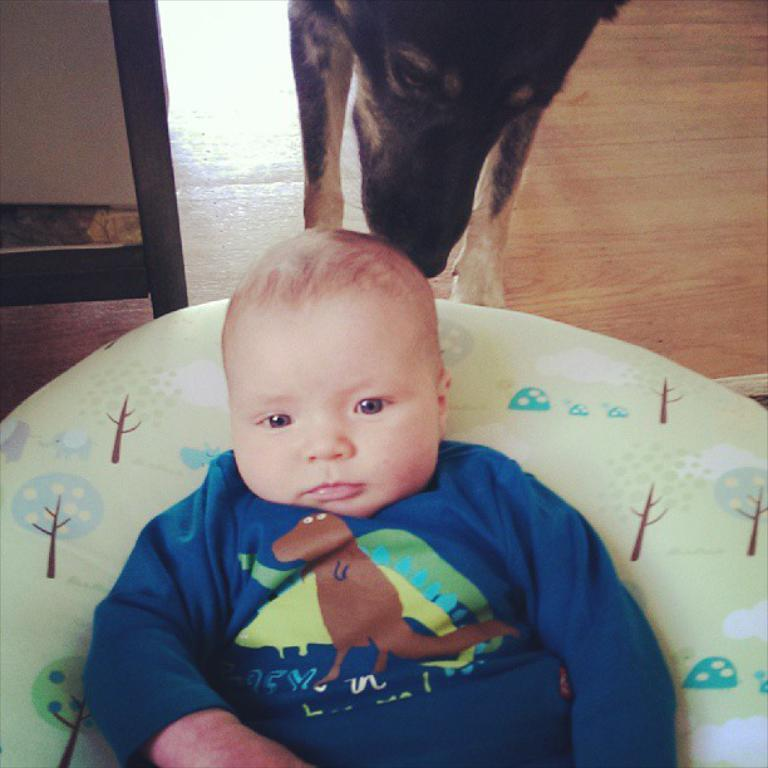What is the main subject of the image? There is a baby in the image. Where is the baby sitting? The baby is sitting on a bean bag. Are there any animals in the image? Yes, there is a dog in the image. Can you describe the position of the dog in relation to the baby? The dog is behind the baby. What type of beef is being served in the image? There is no beef present in the image; it features a baby sitting on a bean bag with a dog behind them. 